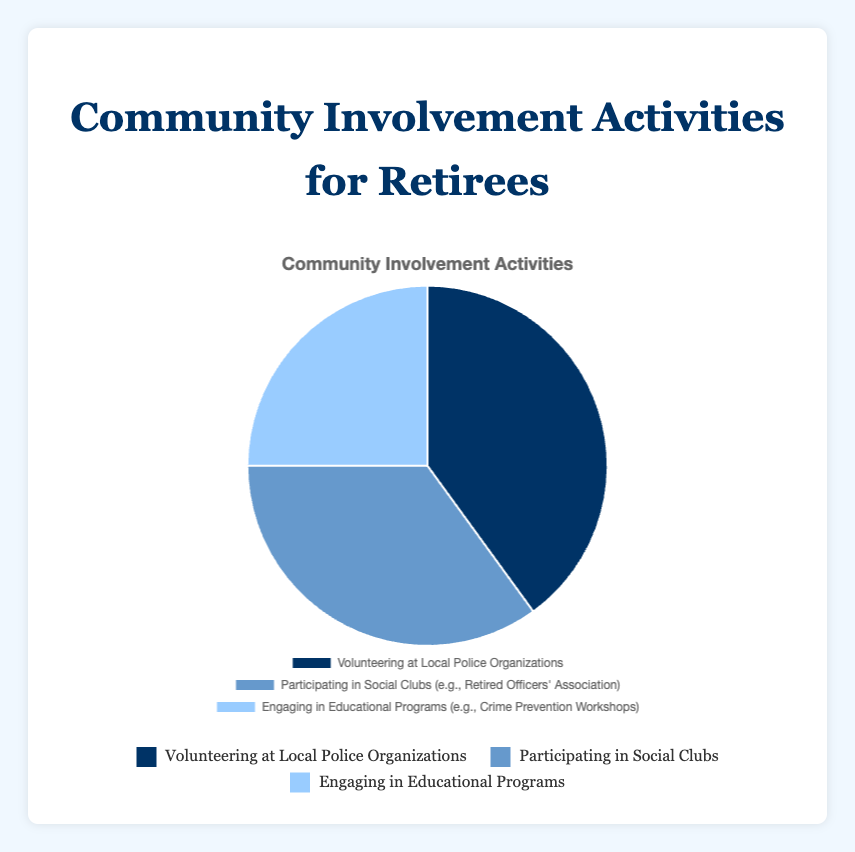What percentage of retirees engage in educational programs? The pie chart lists the percentages directly. The segment labeled "Engaging in Educational Programs (e.g., Crime Prevention Workshops)" shows 25%.
Answer: 25% Which community involvement activity has the highest percentage? By looking at the pie chart, the largest segment represents "Volunteering at Local Police Organizations" with 40%.
Answer: Volunteering at Local Police Organizations What is the difference between the percentage of retirees participating in social clubs and those engaging in educational programs? Subtract the percentage of retirees engaging in educational programs (25%) from those participating in social clubs (35%): 35% - 25% = 10%.
Answer: 10% What is the combined percentage of retirees involved in volunteering and participating in social clubs? Add the percentages of volunteering (40%) and social clubs (35%): 40% + 35% = 75%.
Answer: 75% How does the percentage of retirees volunteering compare to those participating in educational programs? The percentage of retirees volunteering (40%) is greater than those engaging in educational programs (25%).
Answer: Volunteering is greater Identify by color, the activity with the smallest percentage in the pie chart. The smallest segment in the pie chart is for "Engaging in Educational Programs (e.g., Crime Prevention Workshops)" and it is depicted in a light blue color.
Answer: Light blue What percentage of retirees are not volunteering at local police organizations? Subtract the percentage of retirees volunteering at local police organizations (40%) from 100%: 100% - 40% = 60%.
Answer: 60% If we consider social clubs and educational programs together, what fraction of the total do they represent? Combined, social clubs (35%) and educational programs (25%) sum to 60%. As a fraction of 100%, this is 60/100 = 3/5.
Answer: 3/5 